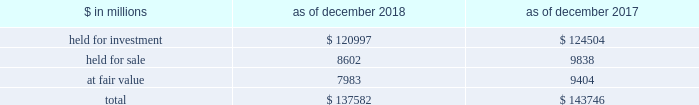The goldman sachs group , inc .
And subsidiaries notes to consolidated financial statements lending commitments the firm 2019s lending commitments are agreements to lend with fixed termination dates and depend on the satisfaction of all contractual conditions to borrowing .
These commitments are presented net of amounts syndicated to third parties .
The total commitment amount does not necessarily reflect actual future cash flows because the firm may syndicate all or substantial additional portions of these commitments .
In addition , commitments can expire unused or be reduced or cancelled at the counterparty 2019s request .
The table below presents information about lending commitments. .
In the table above : 2030 held for investment lending commitments are accounted for on an accrual basis .
See note 9 for further information about such commitments .
2030 held for sale lending commitments are accounted for at the lower of cost or fair value .
2030 gains or losses related to lending commitments at fair value , if any , are generally recorded , net of any fees in other principal transactions .
2030 substantially all lending commitments relates to the firm 2019s investing & lending segment .
Commercial lending .
The firm 2019s commercial lending commitments were primarily extended to investment-grade corporate borrowers .
Such commitments included $ 93.99 billion as of december 2018 and $ 85.98 billion as of december 2017 , related to relationship lending activities ( principally used for operating and general corporate purposes ) and $ 27.92 billion as of december 2018 and $ 42.41 billion as of december 2017 , related to other investment banking activities ( generally extended for contingent acquisition financing and are often intended to be short-term in nature , as borrowers often seek to replace them with other funding sources ) .
The firm also extends lending commitments in connection with other types of corporate lending , as well as commercial real estate financing .
See note 9 for further information about funded loans .
Sumitomo mitsui financial group , inc .
( smfg ) provides the firm with credit loss protection on certain approved loan commitments ( primarily investment-grade commercial lending commitments ) .
The notional amount of such loan commitments was $ 15.52 billion as of december 2018 and $ 25.70 billion as of december 2017 .
The credit loss protection on loan commitments provided by smfg is generally limited to 95% ( 95 % ) of the first loss the firm realizes on such commitments , up to a maximum of approximately $ 950 million .
In addition , subject to the satisfaction of certain conditions , upon the firm 2019s request , smfg will provide protection for 70% ( 70 % ) of additional losses on such commitments , up to a maximum of $ 1.0 billion , of which $ 550 million of protection had been provided as of both december 2018 and december 2017 .
The firm also uses other financial instruments to mitigate credit risks related to certain commitments not covered by smfg .
These instruments primarily include credit default swaps that reference the same or similar underlying instrument or entity , or credit default swaps that reference a market index .
Warehouse financing .
The firm provides financing to clients who warehouse financial assets .
These arrangements are secured by the warehoused assets , primarily consisting of consumer and corporate loans .
Contingent and forward starting collateralized agreements / forward starting collateralized financings forward starting collateralized agreements includes resale and securities borrowing agreements , and forward starting collateralized financings includes repurchase and secured lending agreements that settle at a future date , generally within three business days .
The firm also enters into commitments to provide contingent financing to its clients and counterparties through resale agreements .
The firm 2019s funding of these commitments depends on the satisfaction of all contractual conditions to the resale agreement and these commitments can expire unused .
Letters of credit the firm has commitments under letters of credit issued by various banks which the firm provides to counterparties in lieu of securities or cash to satisfy various collateral and margin deposit requirements .
Investment commitments investment commitments includes commitments to invest in private equity , real estate and other assets directly and through funds that the firm raises and manages .
Investment commitments included $ 2.42 billion as of december 2018 and $ 2.09 billion as of december 2017 , related to commitments to invest in funds managed by the firm .
If these commitments are called , they would be funded at market value on the date of investment .
Goldman sachs 2018 form 10-k 159 .
What is the growth rate in the balance of total lending commitments in 2018? 
Computations: ((137582 - 143746) / 143746)
Answer: -0.04288. 